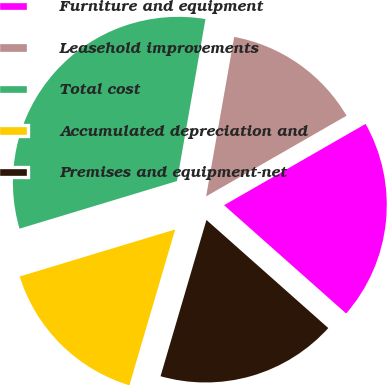<chart> <loc_0><loc_0><loc_500><loc_500><pie_chart><fcel>Furniture and equipment<fcel>Leasehold improvements<fcel>Total cost<fcel>Accumulated depreciation and<fcel>Premises and equipment-net<nl><fcel>19.85%<fcel>13.93%<fcel>32.45%<fcel>15.78%<fcel>18.0%<nl></chart> 